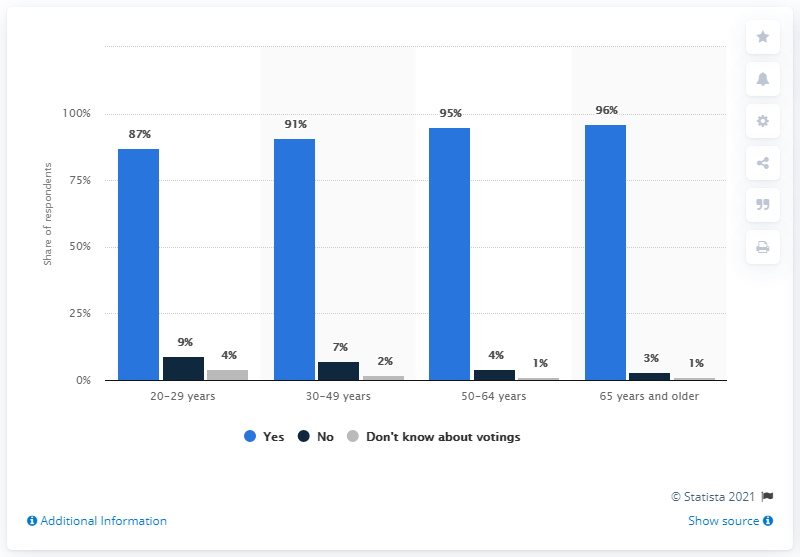List a handful of essential elements in this visual. It is reported that 9% of respondents aged 20 to 29 years stated that they will not be casting a vote in the upcoming general elections. 